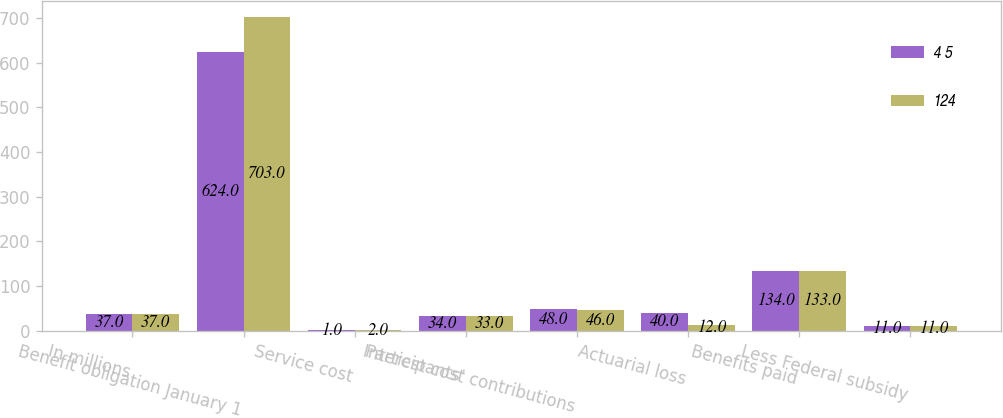Convert chart to OTSL. <chart><loc_0><loc_0><loc_500><loc_500><stacked_bar_chart><ecel><fcel>In millions<fcel>Benefit obligation January 1<fcel>Service cost<fcel>Interest cost<fcel>Participants' contributions<fcel>Actuarial loss<fcel>Benefits paid<fcel>Less Federal subsidy<nl><fcel>4 5<fcel>37<fcel>624<fcel>1<fcel>34<fcel>48<fcel>40<fcel>134<fcel>11<nl><fcel>124<fcel>37<fcel>703<fcel>2<fcel>33<fcel>46<fcel>12<fcel>133<fcel>11<nl></chart> 